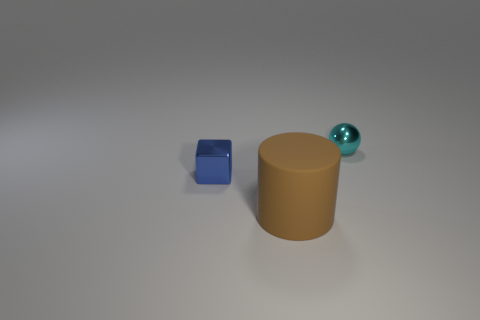Is there any other thing that has the same shape as the blue object?
Ensure brevity in your answer.  No. Is there anything else that has the same size as the brown matte object?
Offer a very short reply. No. There is a blue metal block; are there any cyan metal spheres to the right of it?
Offer a terse response. Yes. The object that is both right of the blue cube and left of the cyan metal object is made of what material?
Your response must be concise. Rubber. Are there any small objects behind the tiny object that is in front of the tiny metal ball?
Ensure brevity in your answer.  Yes. What size is the cyan metallic object?
Your answer should be very brief. Small. There is a thing that is in front of the cyan ball and to the right of the small blue shiny thing; what is its shape?
Your answer should be very brief. Cylinder. How many cyan objects are large matte cylinders or cubes?
Make the answer very short. 0. Do the metal object that is on the left side of the tiny cyan ball and the thing that is in front of the tiny shiny cube have the same size?
Provide a succinct answer. No. How many objects are either rubber cylinders or small blue cubes?
Make the answer very short. 2. 